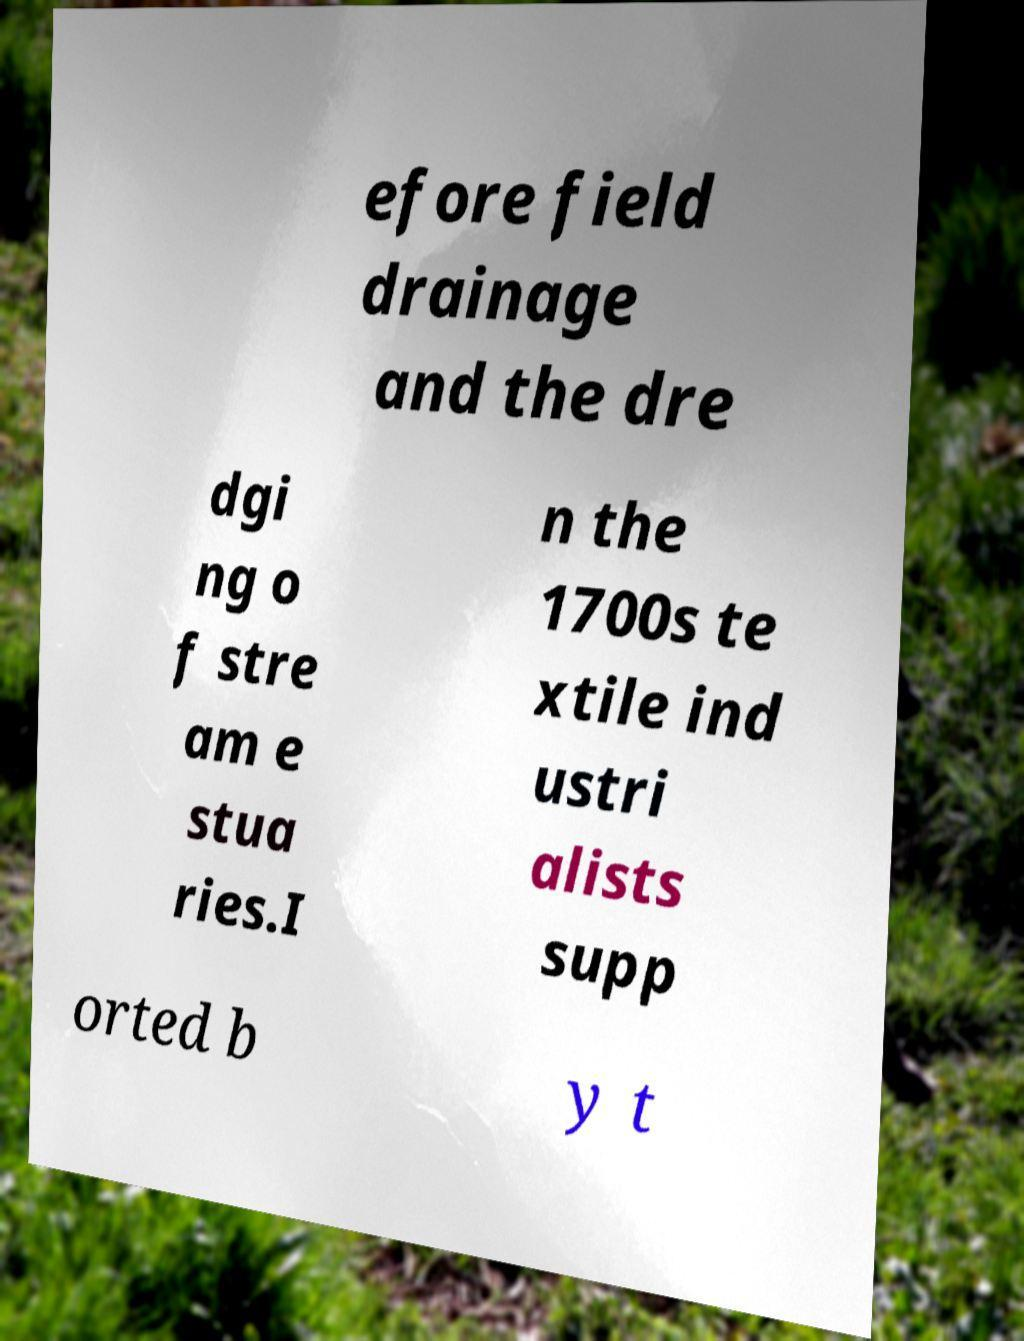I need the written content from this picture converted into text. Can you do that? efore field drainage and the dre dgi ng o f stre am e stua ries.I n the 1700s te xtile ind ustri alists supp orted b y t 